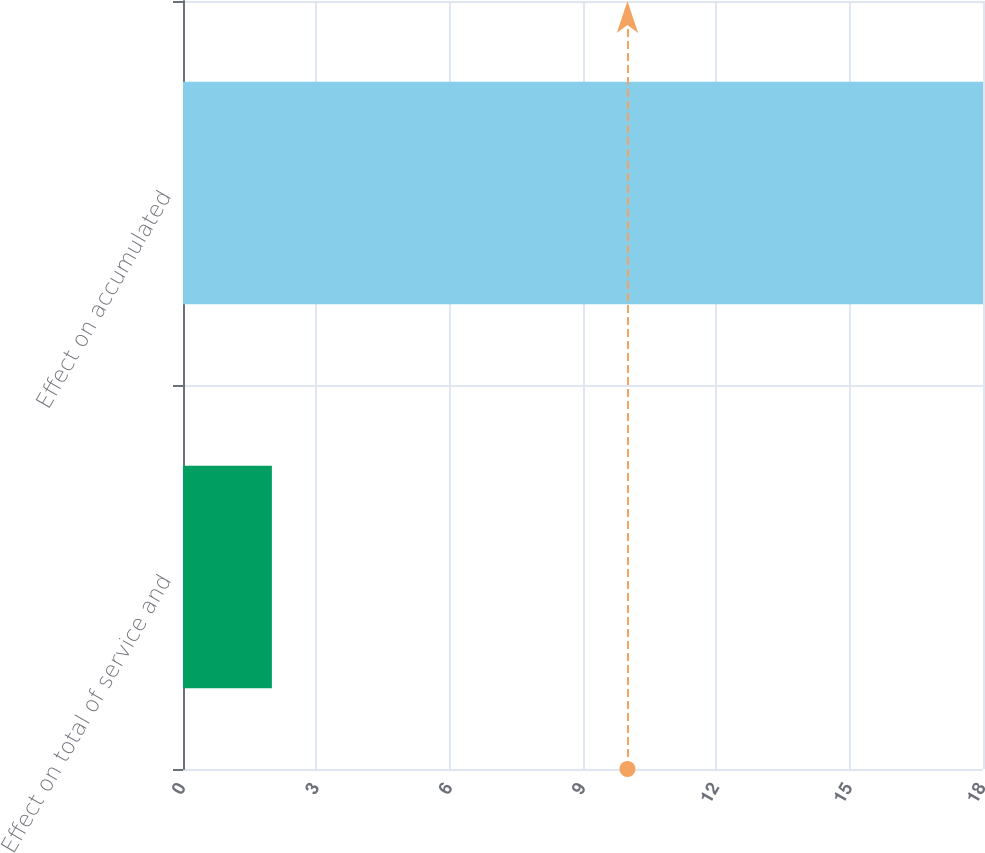Convert chart. <chart><loc_0><loc_0><loc_500><loc_500><bar_chart><fcel>Effect on total of service and<fcel>Effect on accumulated<nl><fcel>2<fcel>18<nl></chart> 